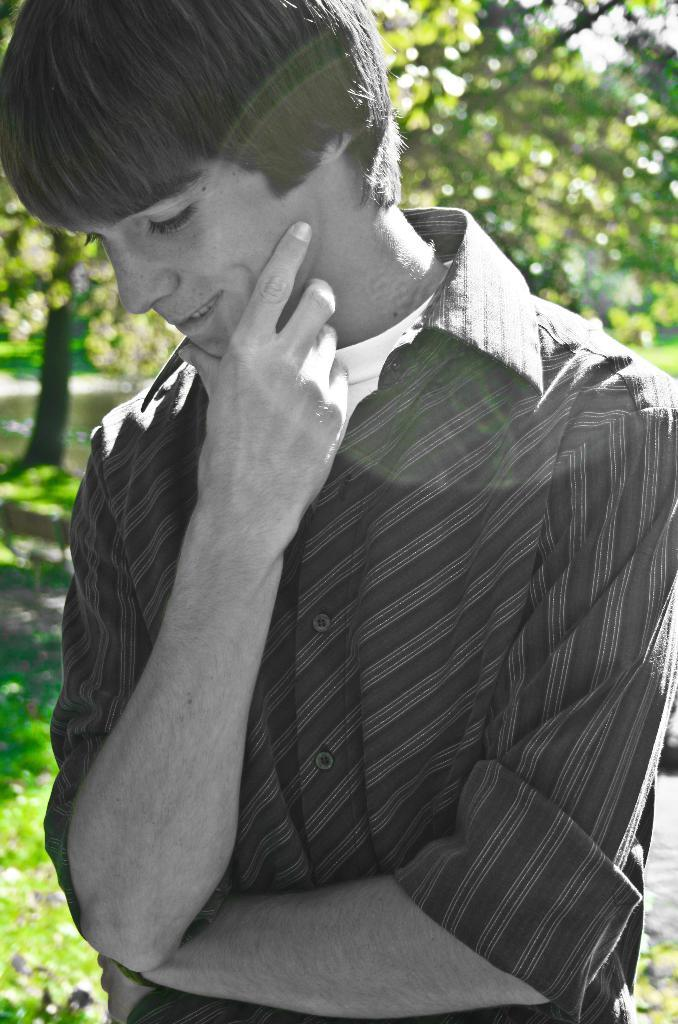What is the person in the image doing with their gaze? The person in the image is looking downwards. How would you describe the background of the image? The background of the image is blurred. What type of vegetation can be seen in the image? There are trees and grass visible in the image. What type of pipe is visible in the image? There is no pipe present in the image. How does the sun appear in the image? The sun is not visible in the image; only the blurred background and vegetation are present. 